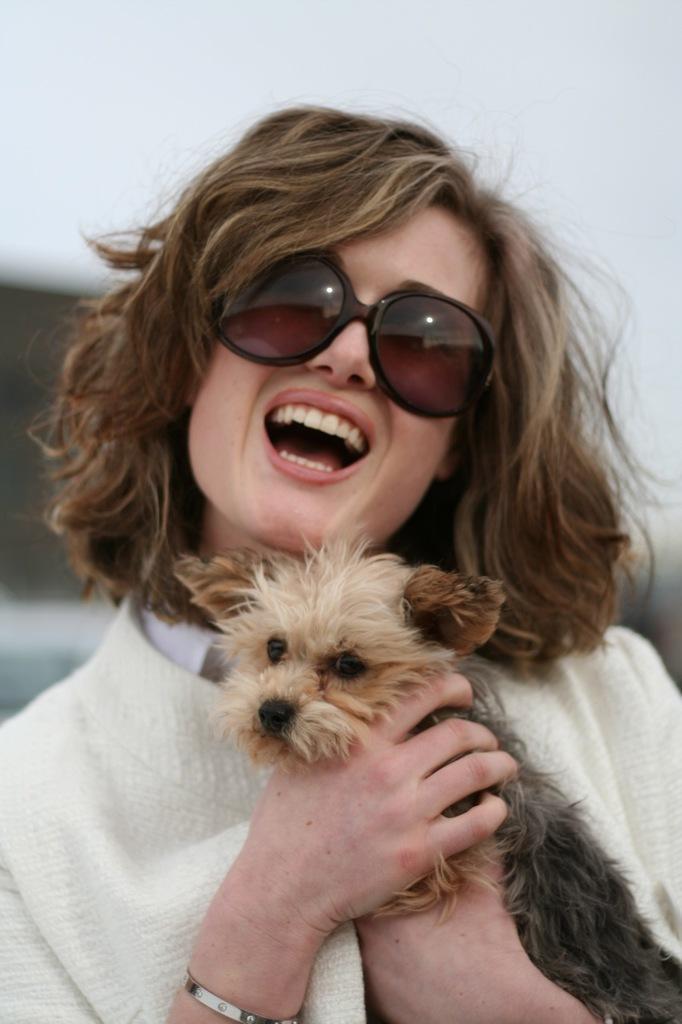Can you describe this image briefly? In this image there a women she is a wearing a white color coat and holding a cat she is wearing a glasses and in the background there is white color. 